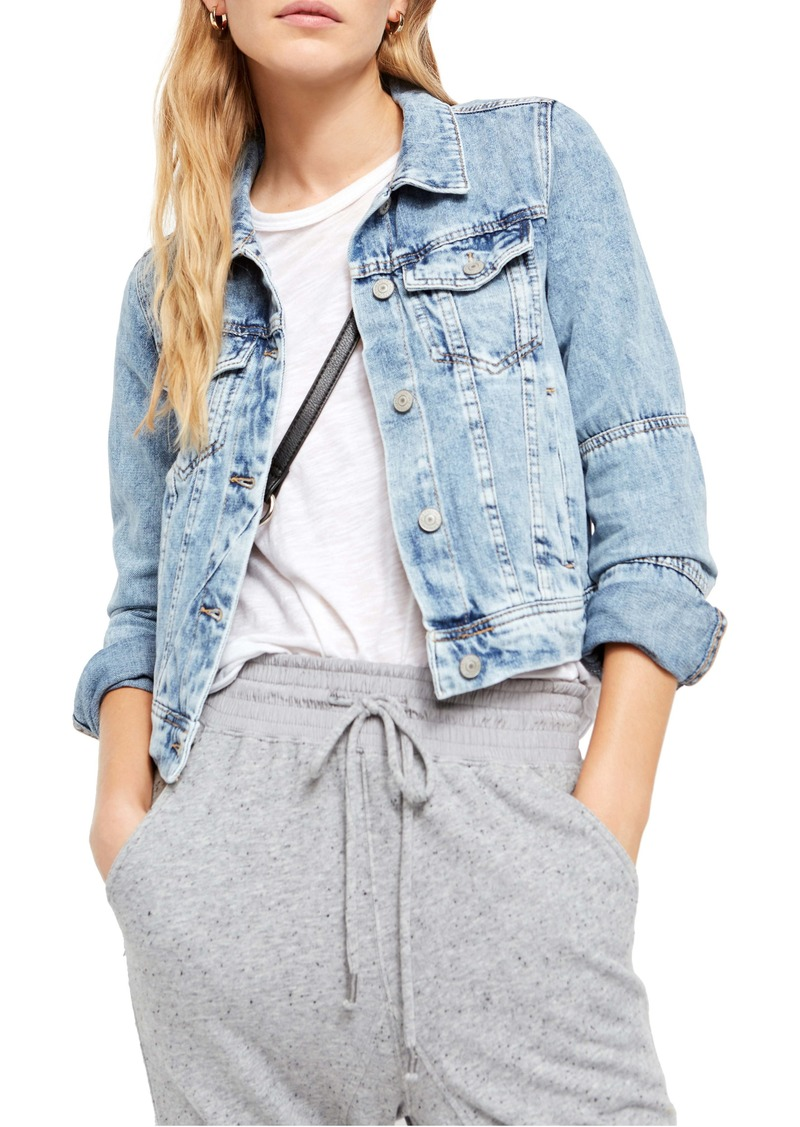Considering the visible accessories and the style of clothes, what might be the age range of the woman? Based on the visible denim jacket, white t-shirt, and grey sweatpants, combined with the small, black cross-body bag, the woman is likely styled in a manner typical of late teens to thirties. These choices are indicative of a casual yet fashionable look favored by millennials and Gen Z for its comfort and stylish simplicity. Denim jackets and minimalistic t-shirts are timeless yet current, often reflecting a youthful aesthetic prevalent in urban and casual fashion circles. While exact age cannot be pinpointed without more personal details, the outfit aligns with modern, youthful trends. 